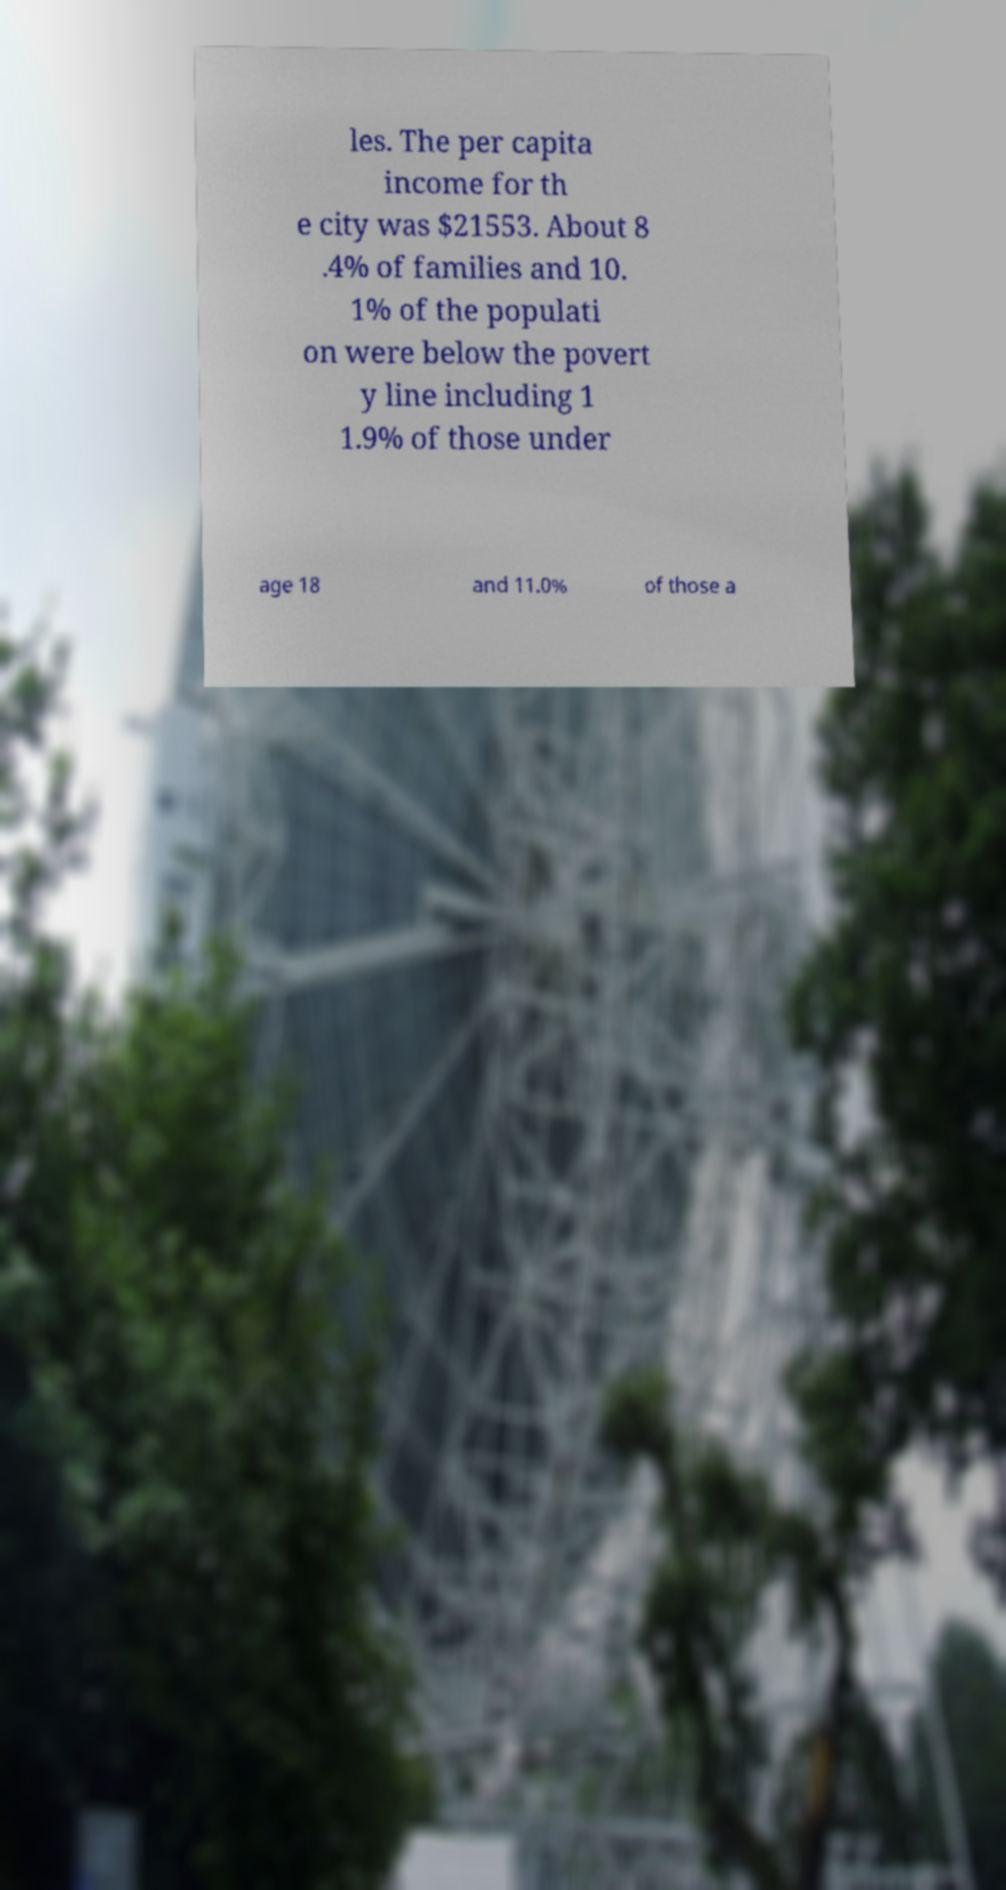There's text embedded in this image that I need extracted. Can you transcribe it verbatim? les. The per capita income for th e city was $21553. About 8 .4% of families and 10. 1% of the populati on were below the povert y line including 1 1.9% of those under age 18 and 11.0% of those a 